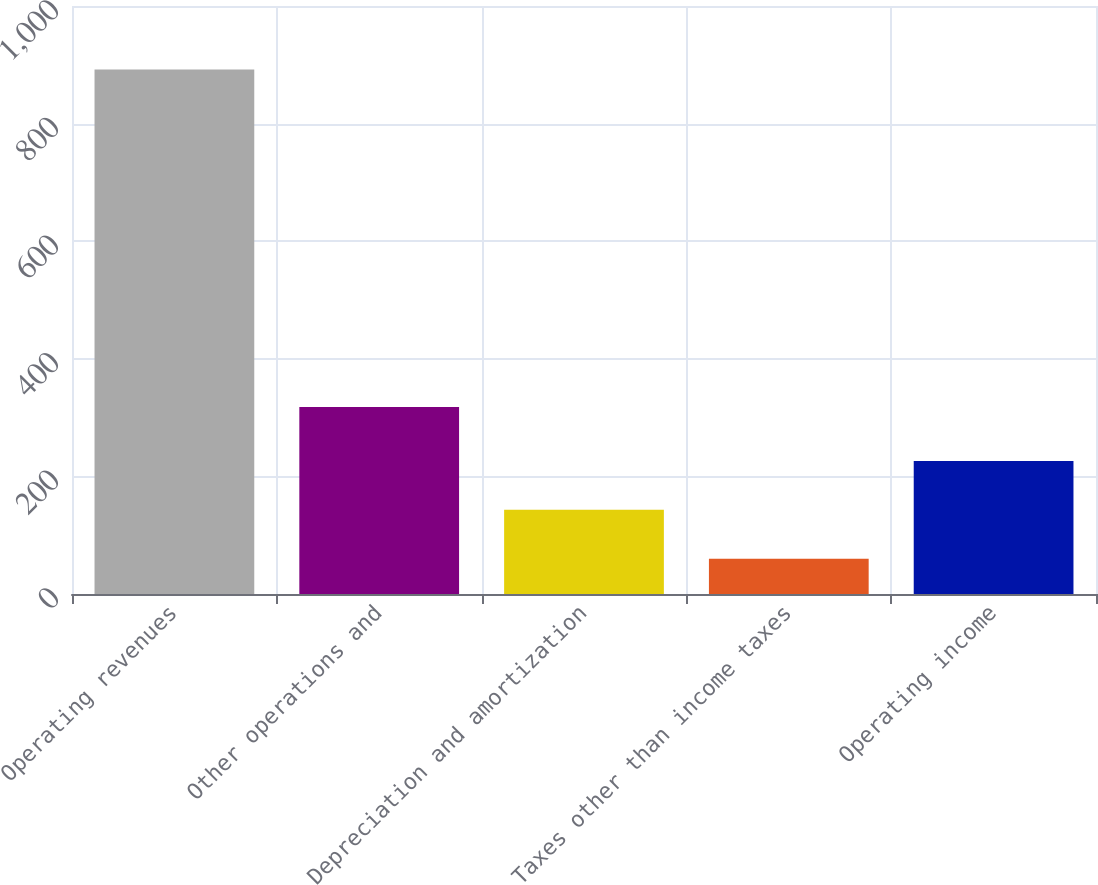<chart> <loc_0><loc_0><loc_500><loc_500><bar_chart><fcel>Operating revenues<fcel>Other operations and<fcel>Depreciation and amortization<fcel>Taxes other than income taxes<fcel>Operating income<nl><fcel>892<fcel>318<fcel>143.2<fcel>60<fcel>226.4<nl></chart> 